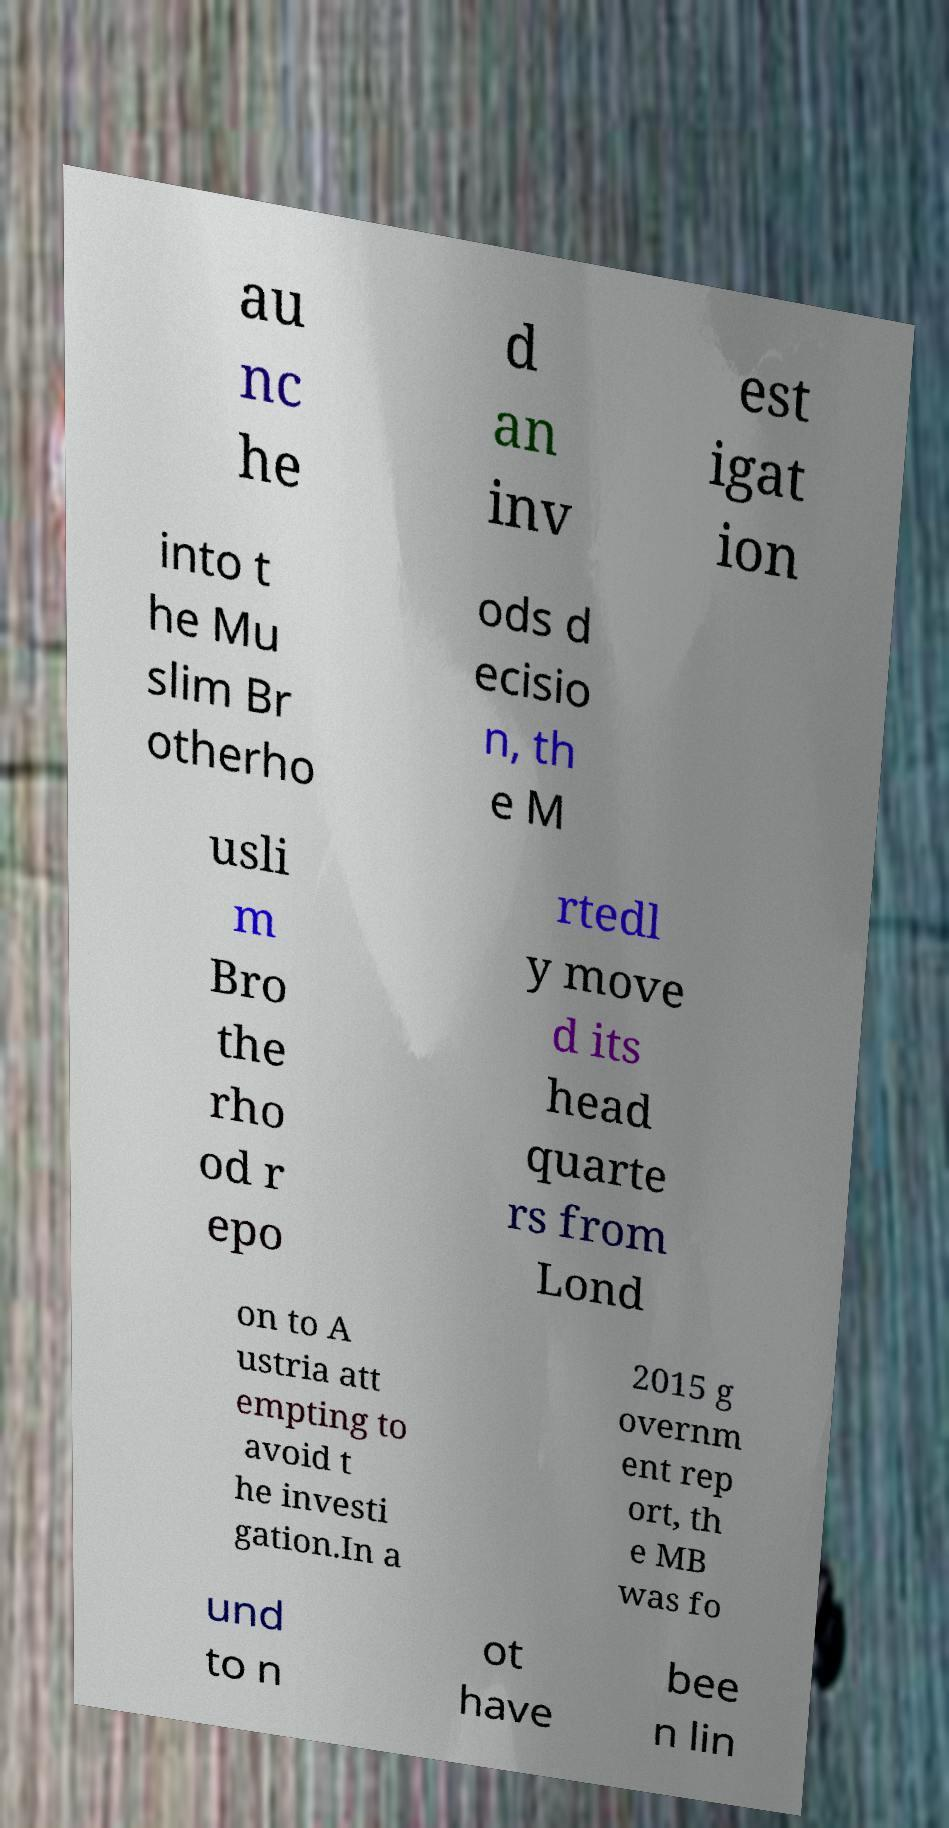Can you read and provide the text displayed in the image?This photo seems to have some interesting text. Can you extract and type it out for me? au nc he d an inv est igat ion into t he Mu slim Br otherho ods d ecisio n, th e M usli m Bro the rho od r epo rtedl y move d its head quarte rs from Lond on to A ustria att empting to avoid t he investi gation.In a 2015 g overnm ent rep ort, th e MB was fo und to n ot have bee n lin 